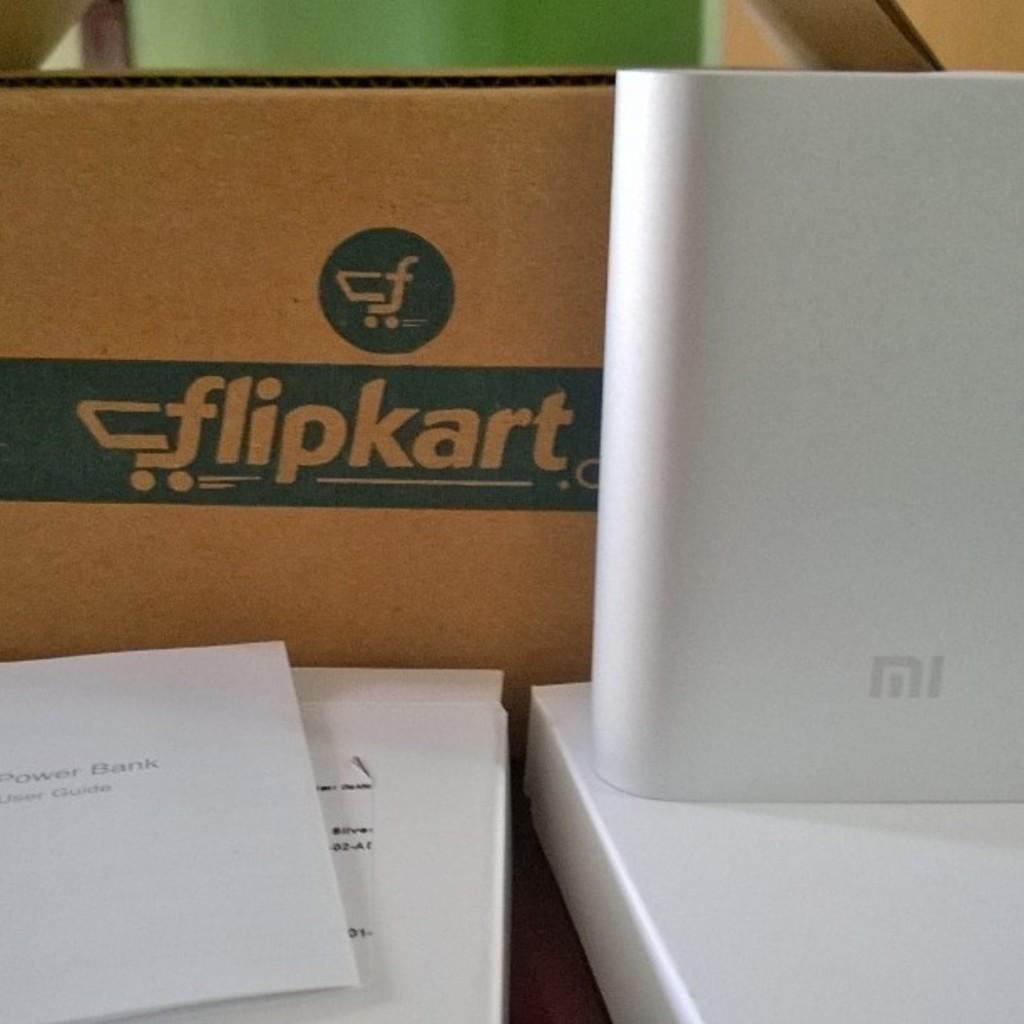What is the name of the company?
Your answer should be compact. Flipkart. 